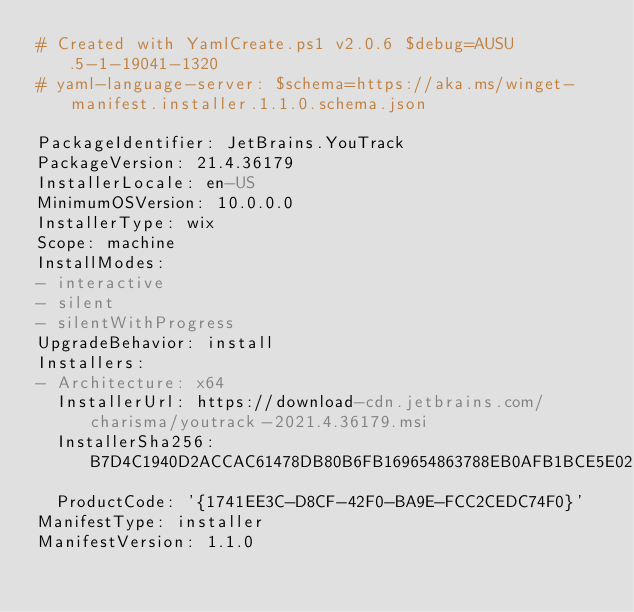Convert code to text. <code><loc_0><loc_0><loc_500><loc_500><_YAML_># Created with YamlCreate.ps1 v2.0.6 $debug=AUSU.5-1-19041-1320
# yaml-language-server: $schema=https://aka.ms/winget-manifest.installer.1.1.0.schema.json

PackageIdentifier: JetBrains.YouTrack
PackageVersion: 21.4.36179
InstallerLocale: en-US
MinimumOSVersion: 10.0.0.0
InstallerType: wix
Scope: machine
InstallModes:
- interactive
- silent
- silentWithProgress
UpgradeBehavior: install
Installers:
- Architecture: x64
  InstallerUrl: https://download-cdn.jetbrains.com/charisma/youtrack-2021.4.36179.msi
  InstallerSha256: B7D4C1940D2ACCAC61478DB80B6FB169654863788EB0AFB1BCE5E02EEDD350D6
  ProductCode: '{1741EE3C-D8CF-42F0-BA9E-FCC2CEDC74F0}'
ManifestType: installer
ManifestVersion: 1.1.0
</code> 